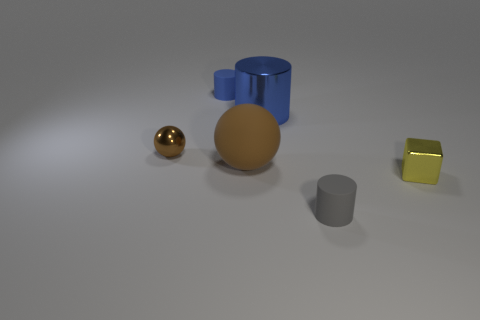Subtract all blue cylinders. How many cylinders are left? 1 Add 3 large metallic cubes. How many objects exist? 9 Subtract all gray cylinders. How many cylinders are left? 2 Subtract 3 cylinders. How many cylinders are left? 0 Subtract all balls. How many objects are left? 4 Add 6 yellow cubes. How many yellow cubes are left? 7 Add 3 brown matte balls. How many brown matte balls exist? 4 Subtract 0 gray balls. How many objects are left? 6 Subtract all red cubes. Subtract all green cylinders. How many cubes are left? 1 Subtract all yellow cubes. How many gray cylinders are left? 1 